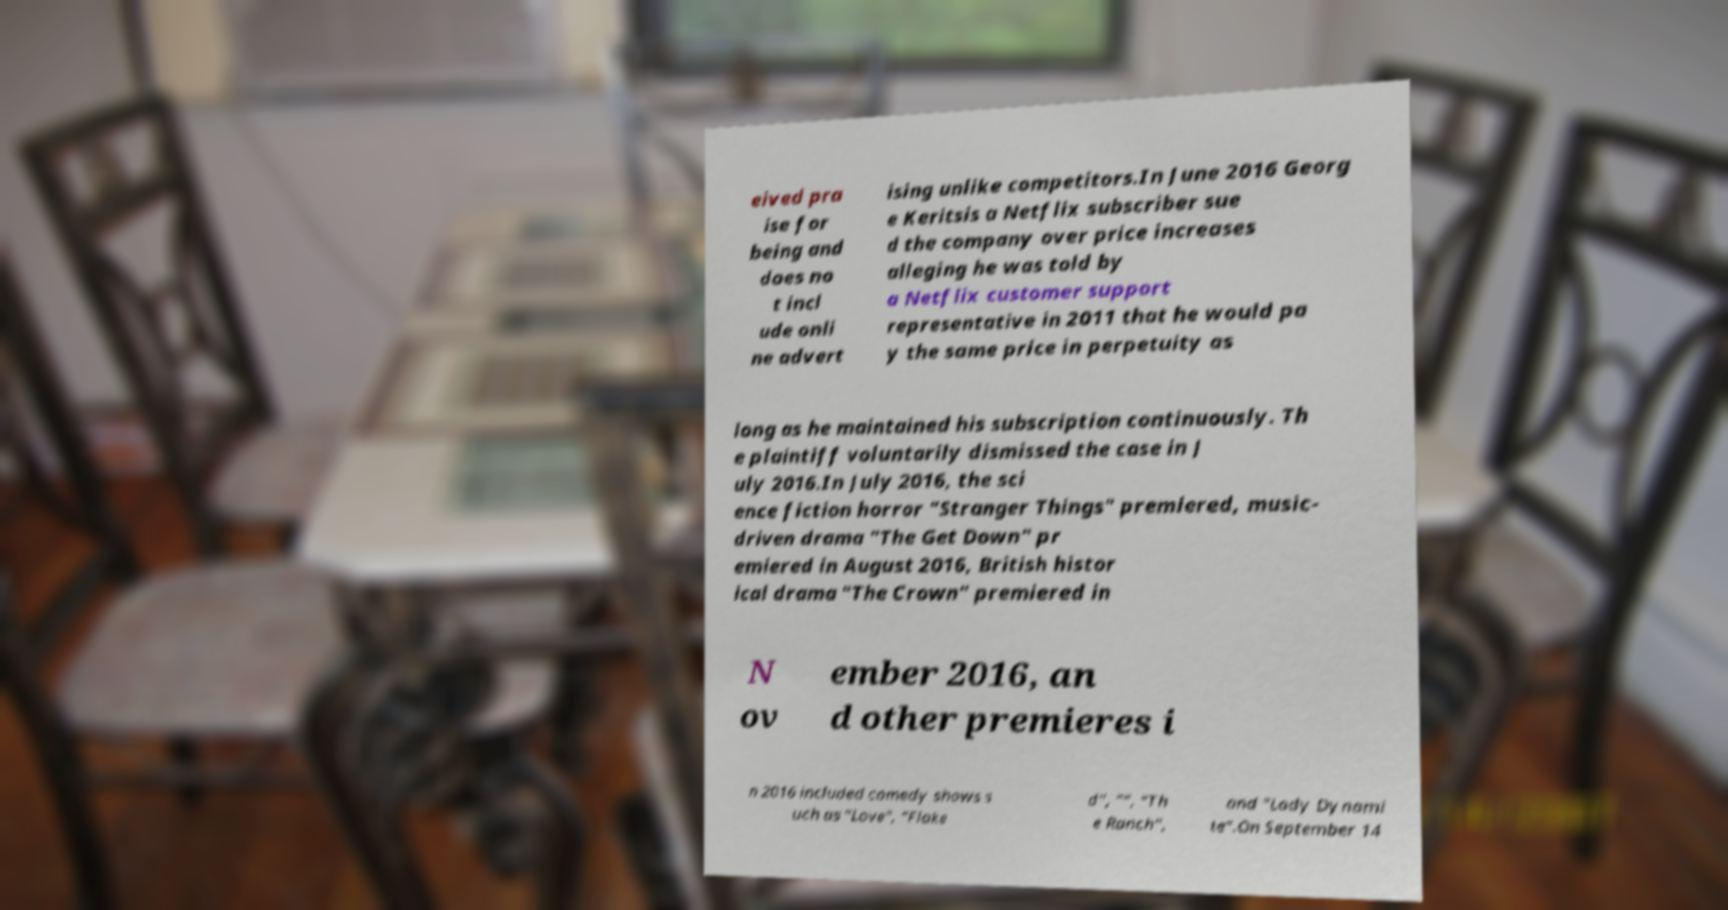Please identify and transcribe the text found in this image. eived pra ise for being and does no t incl ude onli ne advert ising unlike competitors.In June 2016 Georg e Keritsis a Netflix subscriber sue d the company over price increases alleging he was told by a Netflix customer support representative in 2011 that he would pa y the same price in perpetuity as long as he maintained his subscription continuously. Th e plaintiff voluntarily dismissed the case in J uly 2016.In July 2016, the sci ence fiction horror "Stranger Things" premiered, music- driven drama "The Get Down" pr emiered in August 2016, British histor ical drama "The Crown" premiered in N ov ember 2016, an d other premieres i n 2016 included comedy shows s uch as "Love", "Flake d", "", "Th e Ranch", and "Lady Dynami te".On September 14 